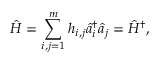Convert formula to latex. <formula><loc_0><loc_0><loc_500><loc_500>\hat { H } = \sum _ { i , j = 1 } ^ { m } h _ { i , j } \hat { a } _ { i } ^ { \dag } \hat { a } _ { j } = \hat { H } ^ { \dag } ,</formula> 